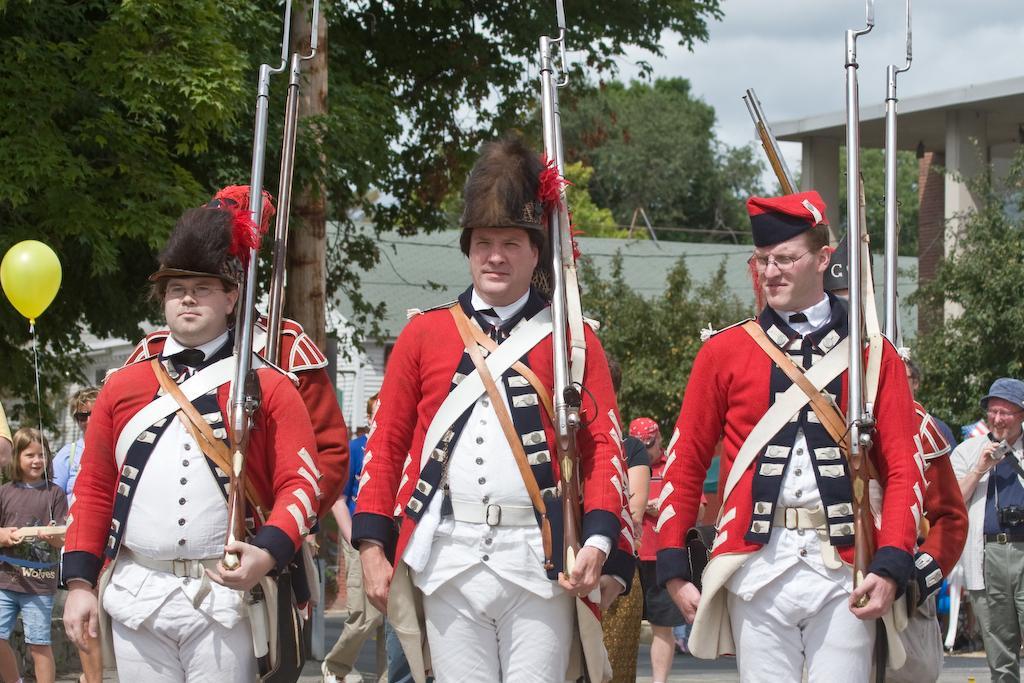How would you summarize this image in a sentence or two? In the image in the center, we can see a few people are standing and they are holding some objects. In the background, we can see the sky, clouds, trees, buildings, one balloon and few people are standing. 